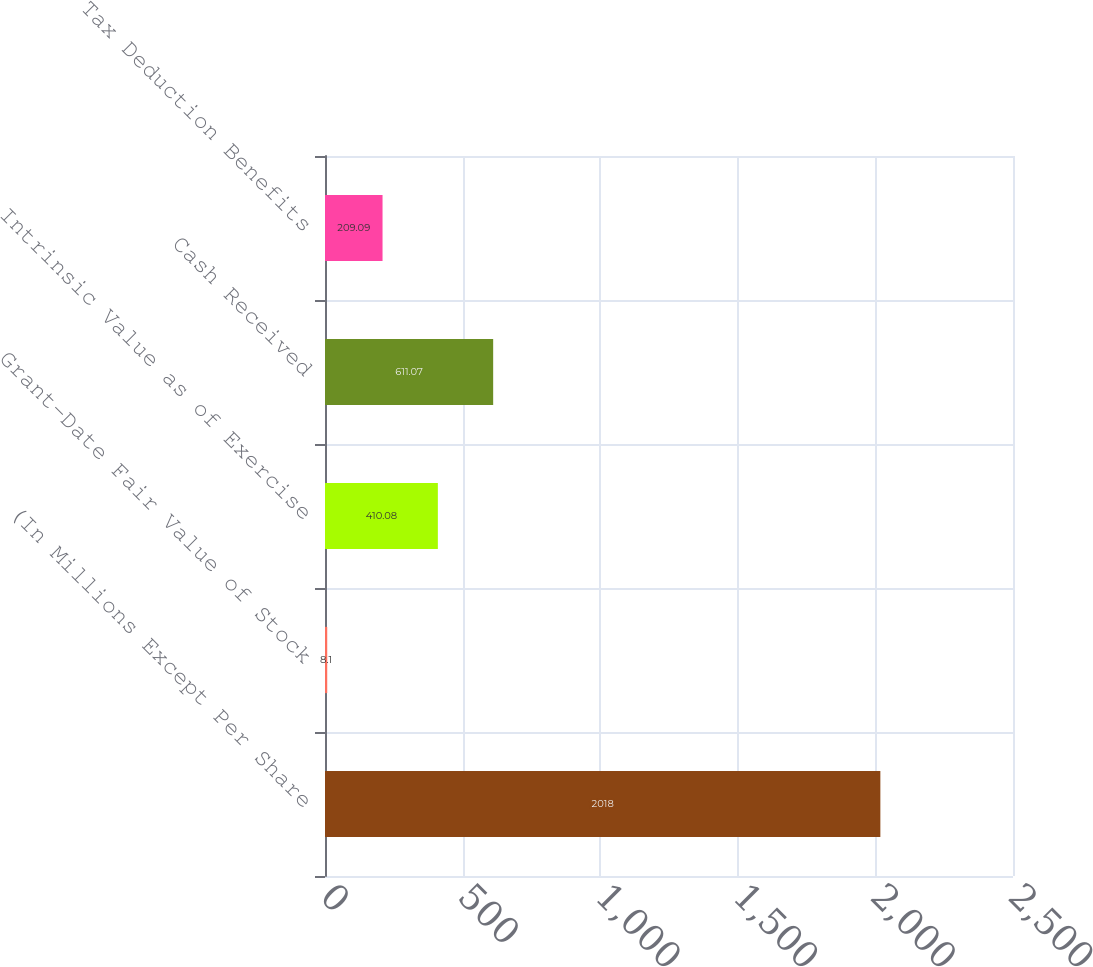Convert chart to OTSL. <chart><loc_0><loc_0><loc_500><loc_500><bar_chart><fcel>(In Millions Except Per Share<fcel>Grant-Date Fair Value of Stock<fcel>Intrinsic Value as of Exercise<fcel>Cash Received<fcel>Tax Deduction Benefits<nl><fcel>2018<fcel>8.1<fcel>410.08<fcel>611.07<fcel>209.09<nl></chart> 